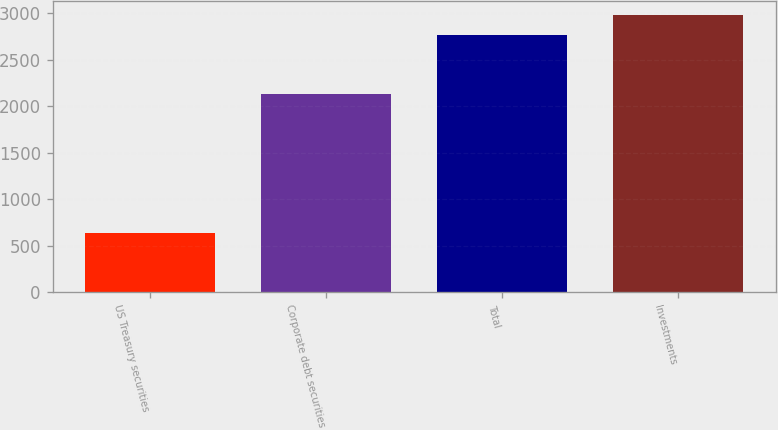<chart> <loc_0><loc_0><loc_500><loc_500><bar_chart><fcel>US Treasury securities<fcel>Corporate debt securities<fcel>Total<fcel>Investments<nl><fcel>635<fcel>2126<fcel>2769<fcel>2982.4<nl></chart> 